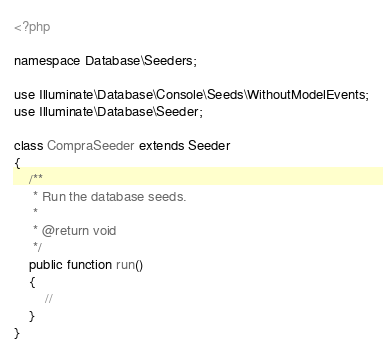<code> <loc_0><loc_0><loc_500><loc_500><_PHP_><?php

namespace Database\Seeders;

use Illuminate\Database\Console\Seeds\WithoutModelEvents;
use Illuminate\Database\Seeder;

class CompraSeeder extends Seeder
{
    /**
     * Run the database seeds.
     *
     * @return void
     */
    public function run()
    {
        //
    }
}
</code> 